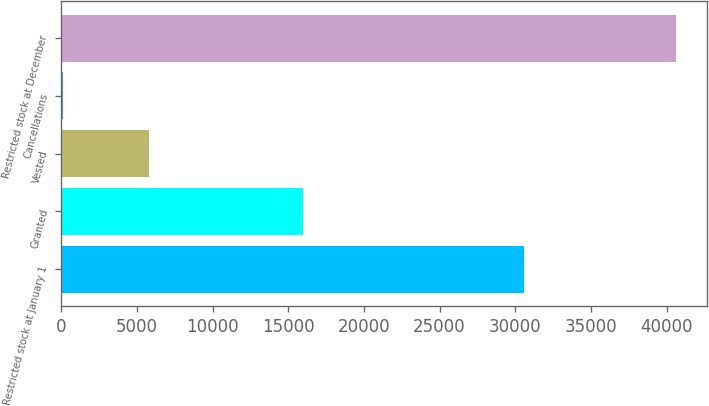<chart> <loc_0><loc_0><loc_500><loc_500><bar_chart><fcel>Restricted stock at January 1<fcel>Granted<fcel>Vested<fcel>Cancellations<fcel>Restricted stock at December<nl><fcel>30600<fcel>16005<fcel>5816<fcel>134<fcel>40655<nl></chart> 